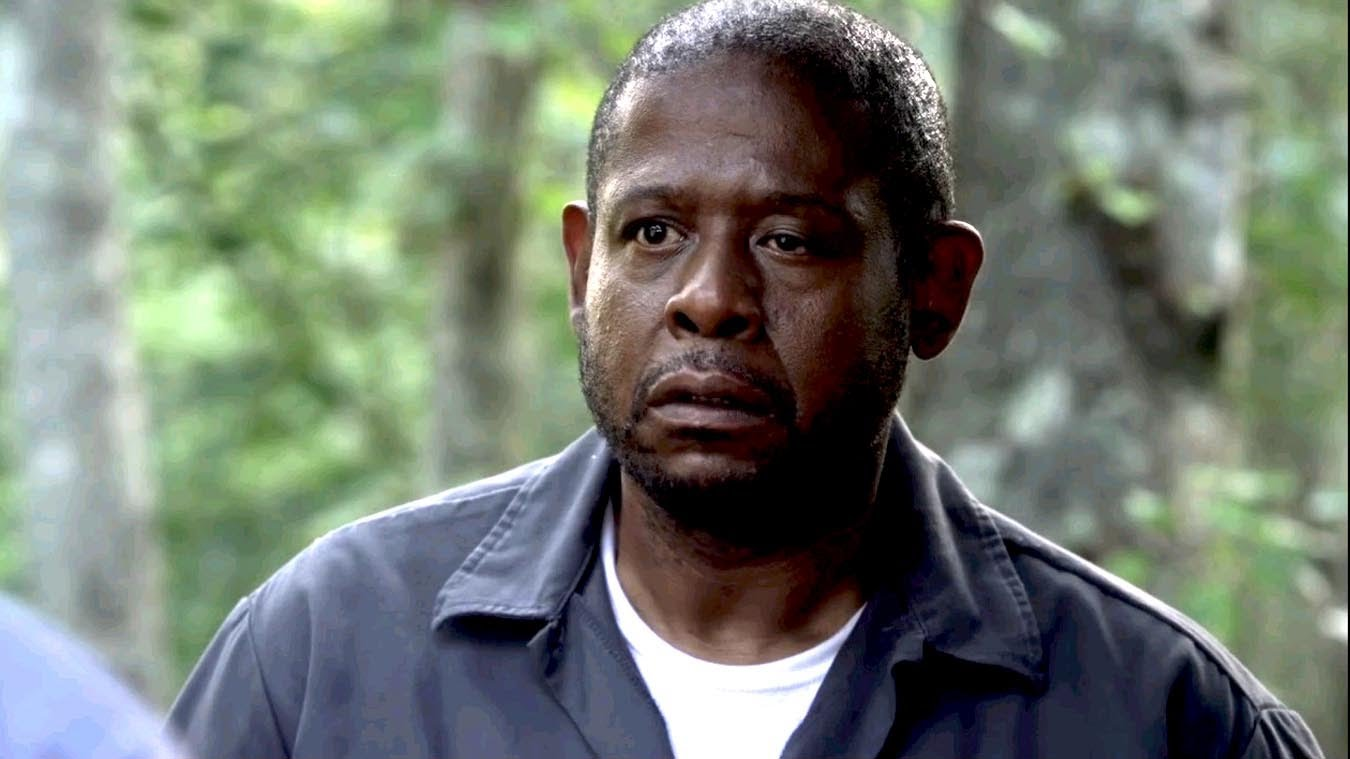What might be going through the character's mind in this scene? The character appears deeply pensive, possibly grappling with a significant decision or confronting a troubling thought. The quiet forest setting may be reflecting his internal solitude or the seriousness of his situation, enhancing the emotional weight of his decision-making. 